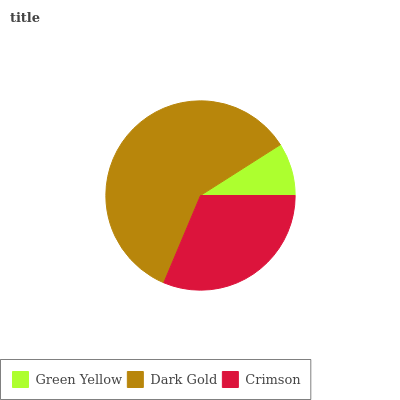Is Green Yellow the minimum?
Answer yes or no. Yes. Is Dark Gold the maximum?
Answer yes or no. Yes. Is Crimson the minimum?
Answer yes or no. No. Is Crimson the maximum?
Answer yes or no. No. Is Dark Gold greater than Crimson?
Answer yes or no. Yes. Is Crimson less than Dark Gold?
Answer yes or no. Yes. Is Crimson greater than Dark Gold?
Answer yes or no. No. Is Dark Gold less than Crimson?
Answer yes or no. No. Is Crimson the high median?
Answer yes or no. Yes. Is Crimson the low median?
Answer yes or no. Yes. Is Green Yellow the high median?
Answer yes or no. No. Is Green Yellow the low median?
Answer yes or no. No. 